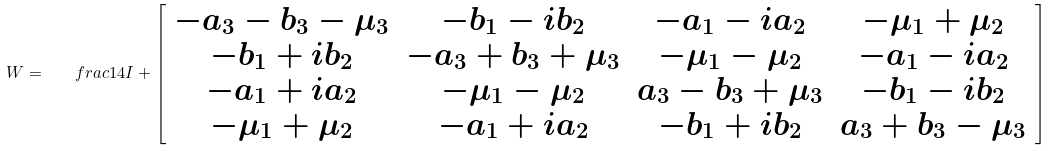Convert formula to latex. <formula><loc_0><loc_0><loc_500><loc_500>W = \quad f r a c { 1 } { 4 } I + \left [ \begin{array} { c c c c } - a _ { 3 } - b _ { 3 } - \mu _ { 3 } & - b _ { 1 } - i b _ { 2 } & - a _ { 1 } - i a _ { 2 } & - \mu _ { 1 } + \mu _ { 2 } \\ - b _ { 1 } + i b _ { 2 } & - a _ { 3 } + b _ { 3 } + \mu _ { 3 } & - \mu _ { 1 } - \mu _ { 2 } & - a _ { 1 } - i a _ { 2 } \\ - a _ { 1 } + i a _ { 2 } & - \mu _ { 1 } - \mu _ { 2 } & a _ { 3 } - b _ { 3 } + \mu _ { 3 } & - b _ { 1 } - i b _ { 2 } \\ - \mu _ { 1 } + \mu _ { 2 } & - a _ { 1 } + i a _ { 2 } & - b _ { 1 } + i b _ { 2 } & a _ { 3 } + b _ { 3 } - \mu _ { 3 } \end{array} \right ]</formula> 